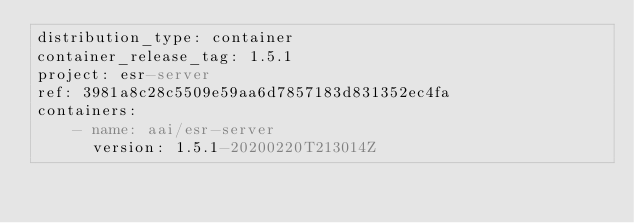Convert code to text. <code><loc_0><loc_0><loc_500><loc_500><_YAML_>distribution_type: container
container_release_tag: 1.5.1
project: esr-server
ref: 3981a8c28c5509e59aa6d7857183d831352ec4fa
containers:
    - name: aai/esr-server
      version: 1.5.1-20200220T213014Z</code> 